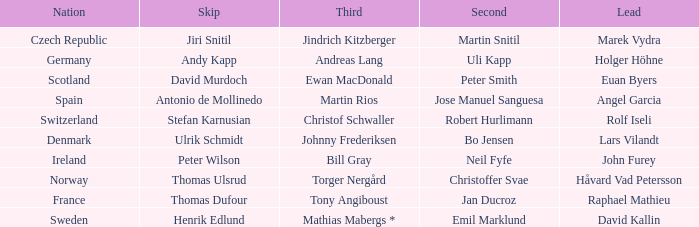Which Skip has a Third of tony angiboust? Thomas Dufour. 